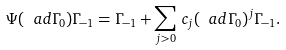Convert formula to latex. <formula><loc_0><loc_0><loc_500><loc_500>\Psi ( \ a d \Gamma _ { 0 } ) \Gamma _ { - 1 } = \Gamma _ { - 1 } + \sum _ { j > 0 } \, c _ { j } ( \ a d \Gamma _ { 0 } ) ^ { j } \Gamma _ { - 1 } .</formula> 